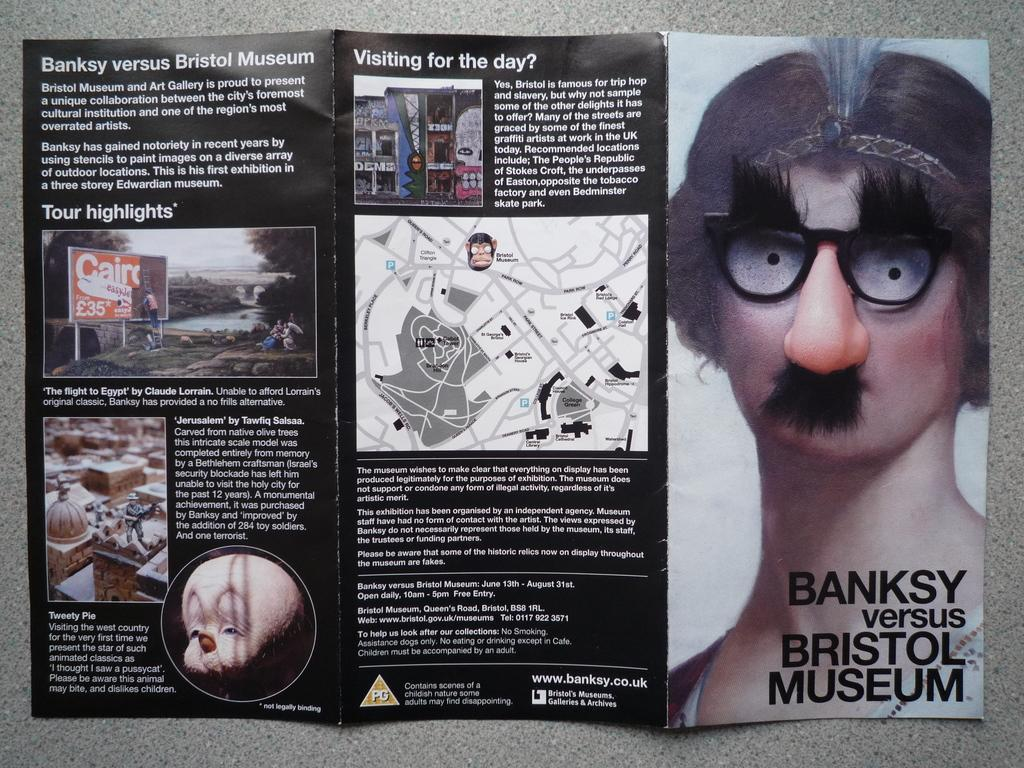What is present in the image that might provide information? There is a pamphlet in the image. Where might the pamphlet be located in the room? The pamphlet may be on the floor. Can you describe the setting of the image? The image is taken in a room. What type of yoke can be seen in the image? There is no yoke present in the image. Is there a giraffe visible in the image? No, there is no giraffe in the image. 